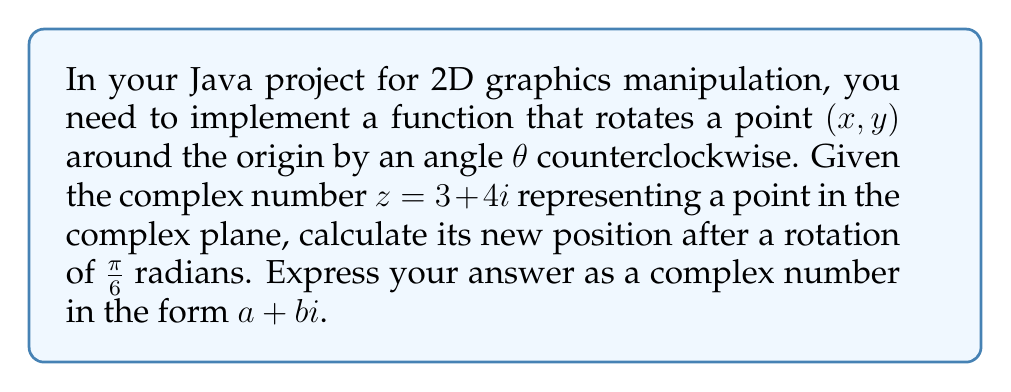Could you help me with this problem? Let's approach this step-by-step:

1) To rotate a point represented by a complex number $z$ by an angle $\theta$ counterclockwise, we multiply $z$ by $e^{i\theta}$:

   $z_{new} = z \cdot e^{i\theta}$

2) In this case, $z = 3 + 4i$ and $\theta = \frac{\pi}{6}$

3) We need to calculate $e^{i\frac{\pi}{6}}$. Recall Euler's formula:

   $e^{i\theta} = \cos\theta + i\sin\theta$

4) So, $e^{i\frac{\pi}{6}} = \cos\frac{\pi}{6} + i\sin\frac{\pi}{6}$

5) $\cos\frac{\pi}{6} = \frac{\sqrt{3}}{2}$ and $\sin\frac{\pi}{6} = \frac{1}{2}$

6) Therefore, $e^{i\frac{\pi}{6}} = \frac{\sqrt{3}}{2} + \frac{1}{2}i$

7) Now, we multiply $z$ by $e^{i\frac{\pi}{6}}$:

   $z_{new} = (3 + 4i) \cdot (\frac{\sqrt{3}}{2} + \frac{1}{2}i)$

8) Expanding this:

   $z_{new} = (3 \cdot \frac{\sqrt{3}}{2} - 4 \cdot \frac{1}{2}) + (3 \cdot \frac{1}{2} + 4 \cdot \frac{\sqrt{3}}{2})i$

9) Simplifying:

   $z_{new} = (\frac{3\sqrt{3}}{2} - 2) + (\frac{3}{2} + 2\sqrt{3})i$

10) This can be further simplified to:

    $z_{new} = (\frac{3\sqrt{3} - 4}{2}) + (\frac{3 + 4\sqrt{3}}{2})i$
Answer: $(\frac{3\sqrt{3} - 4}{2}) + (\frac{3 + 4\sqrt{3}}{2})i$ 